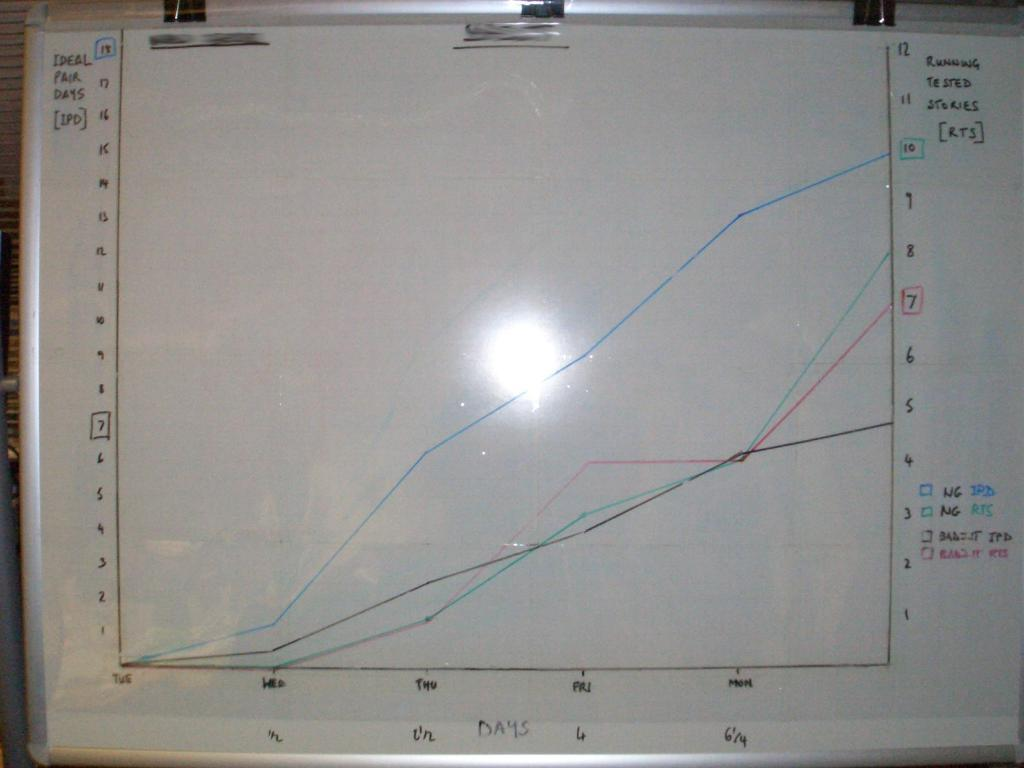<image>
Present a compact description of the photo's key features. White board which says the word "Ideal Pair Days" on the left. 